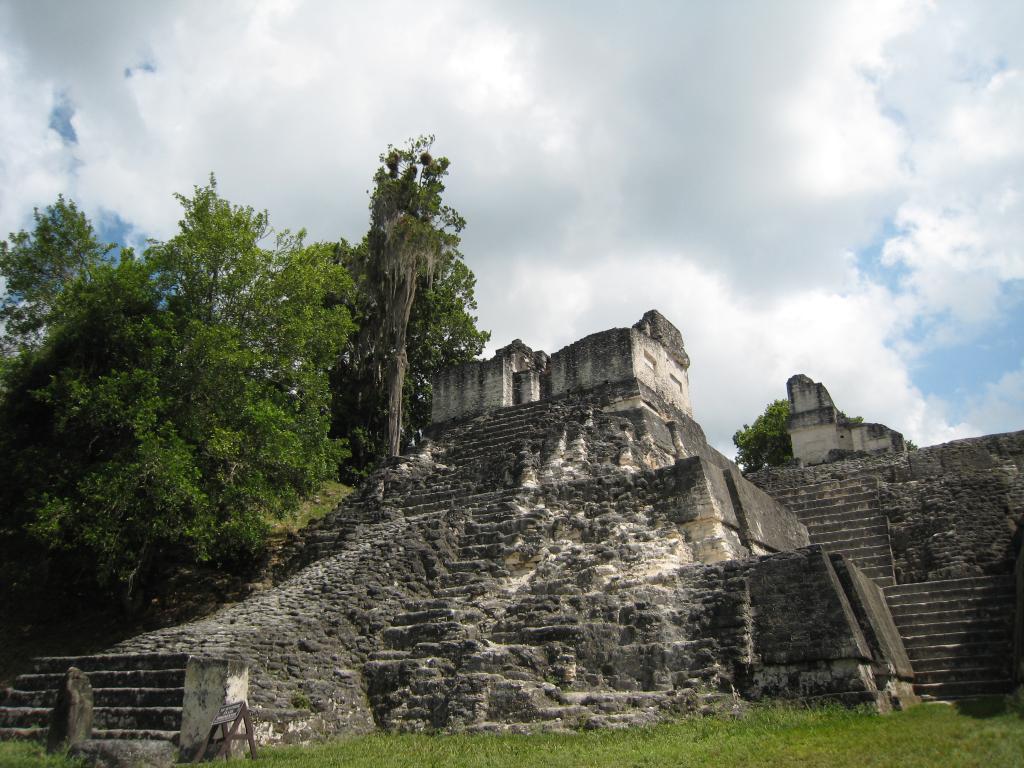Please provide a concise description of this image. In this image I can see grass on the bottom side and on the bottom left side of the image I can see a wooden thing on the ground. I can also see few buildings, few trees and in the background of the image I can see clouds and the sky. 